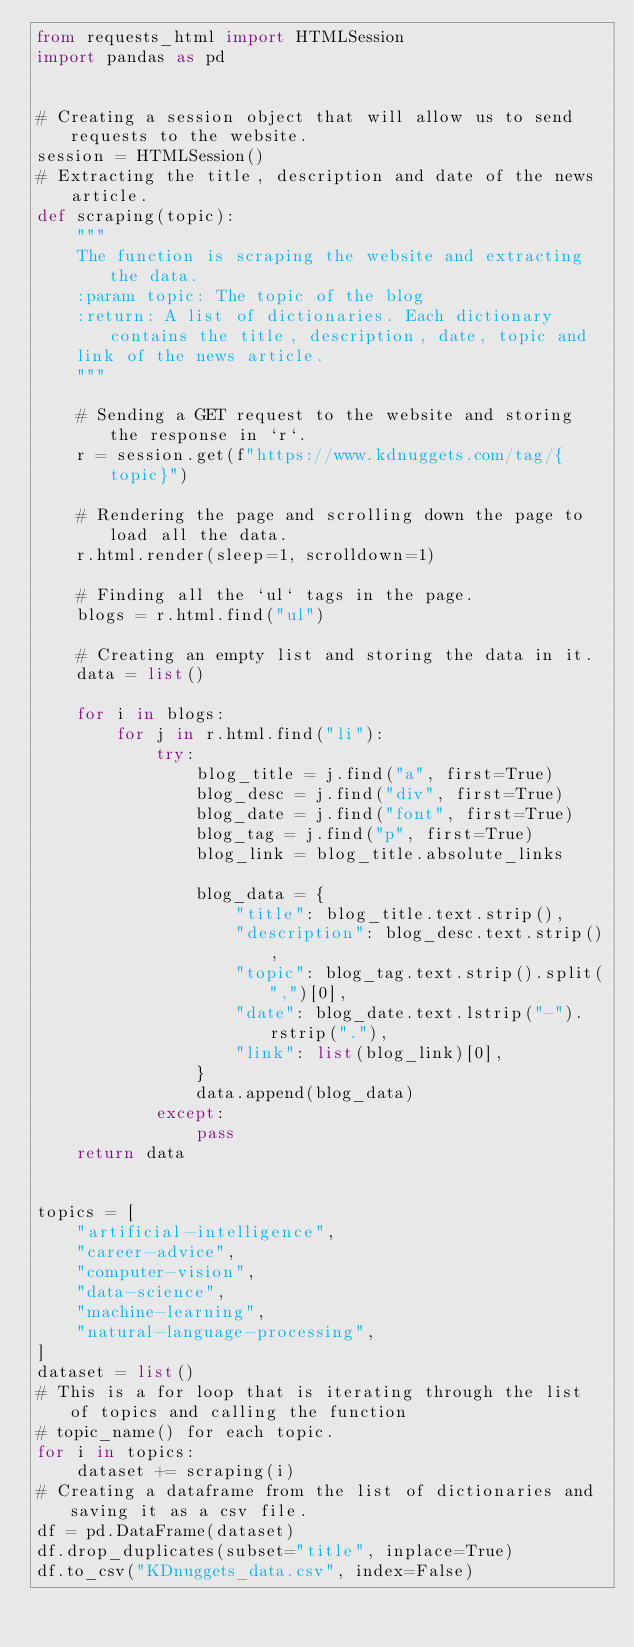<code> <loc_0><loc_0><loc_500><loc_500><_Python_>from requests_html import HTMLSession
import pandas as pd


# Creating a session object that will allow us to send requests to the website.
session = HTMLSession()
# Extracting the title, description and date of the news article.
def scraping(topic):
    """
    The function is scraping the website and extracting the data.
    :param topic: The topic of the blog
    :return: A list of dictionaries. Each dictionary contains the title, description, date, topic and
    link of the news article.
    """

    # Sending a GET request to the website and storing the response in `r`.
    r = session.get(f"https://www.kdnuggets.com/tag/{topic}")

    # Rendering the page and scrolling down the page to load all the data.
    r.html.render(sleep=1, scrolldown=1)

    # Finding all the `ul` tags in the page.
    blogs = r.html.find("ul")

    # Creating an empty list and storing the data in it.
    data = list()

    for i in blogs:
        for j in r.html.find("li"):
            try:
                blog_title = j.find("a", first=True)
                blog_desc = j.find("div", first=True)
                blog_date = j.find("font", first=True)
                blog_tag = j.find("p", first=True)
                blog_link = blog_title.absolute_links

                blog_data = {
                    "title": blog_title.text.strip(),
                    "description": blog_desc.text.strip(),
                    "topic": blog_tag.text.strip().split(",")[0],
                    "date": blog_date.text.lstrip("-").rstrip("."),
                    "link": list(blog_link)[0],
                }
                data.append(blog_data)
            except:
                pass
    return data


topics = [
    "artificial-intelligence",
    "career-advice",
    "computer-vision",
    "data-science",
    "machine-learning",
    "natural-language-processing",
]
dataset = list()
# This is a for loop that is iterating through the list of topics and calling the function
# topic_name() for each topic.
for i in topics:
    dataset += scraping(i)
# Creating a dataframe from the list of dictionaries and saving it as a csv file.
df = pd.DataFrame(dataset)
df.drop_duplicates(subset="title", inplace=True)
df.to_csv("KDnuggets_data.csv", index=False)
</code> 